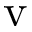<formula> <loc_0><loc_0><loc_500><loc_500>v</formula> 